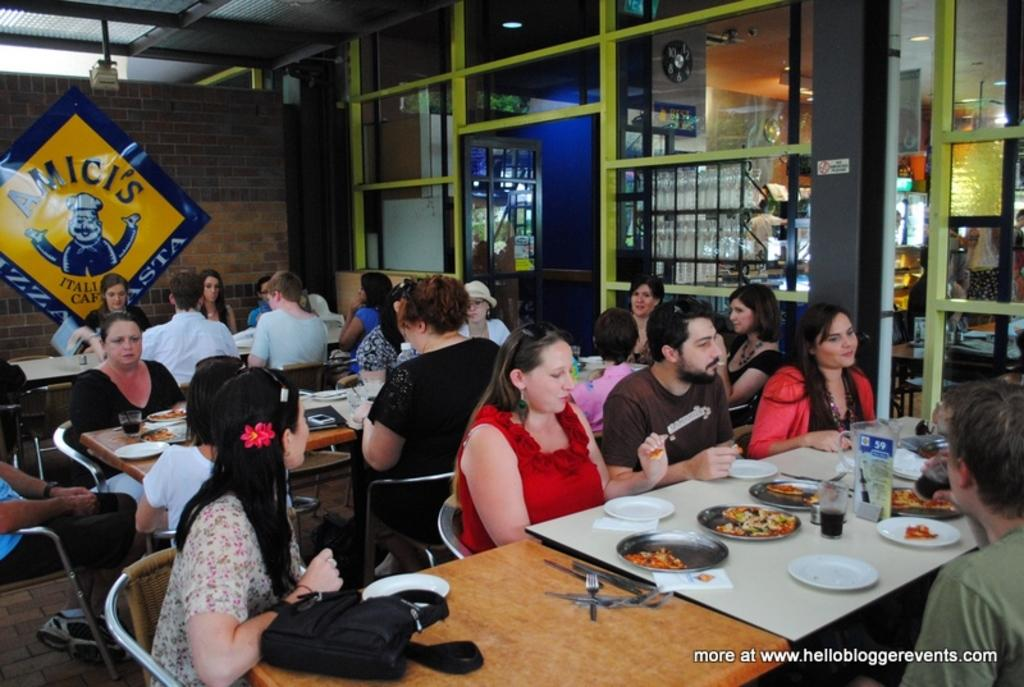How many people are in the image? There is a group of people in the image. What are the people doing in the image? The people are sitting. What is on the table in the image? There is a table in the image, and food is served on plates, beverages are in glasses, and utensils such as spoons and forks are on the table. What type of leaf is being used as a mitten by one of the people in the image? There is no leaf or mitten present in the image. How many matches are visible on the table in the image? There are no matches visible on the table in the image. 